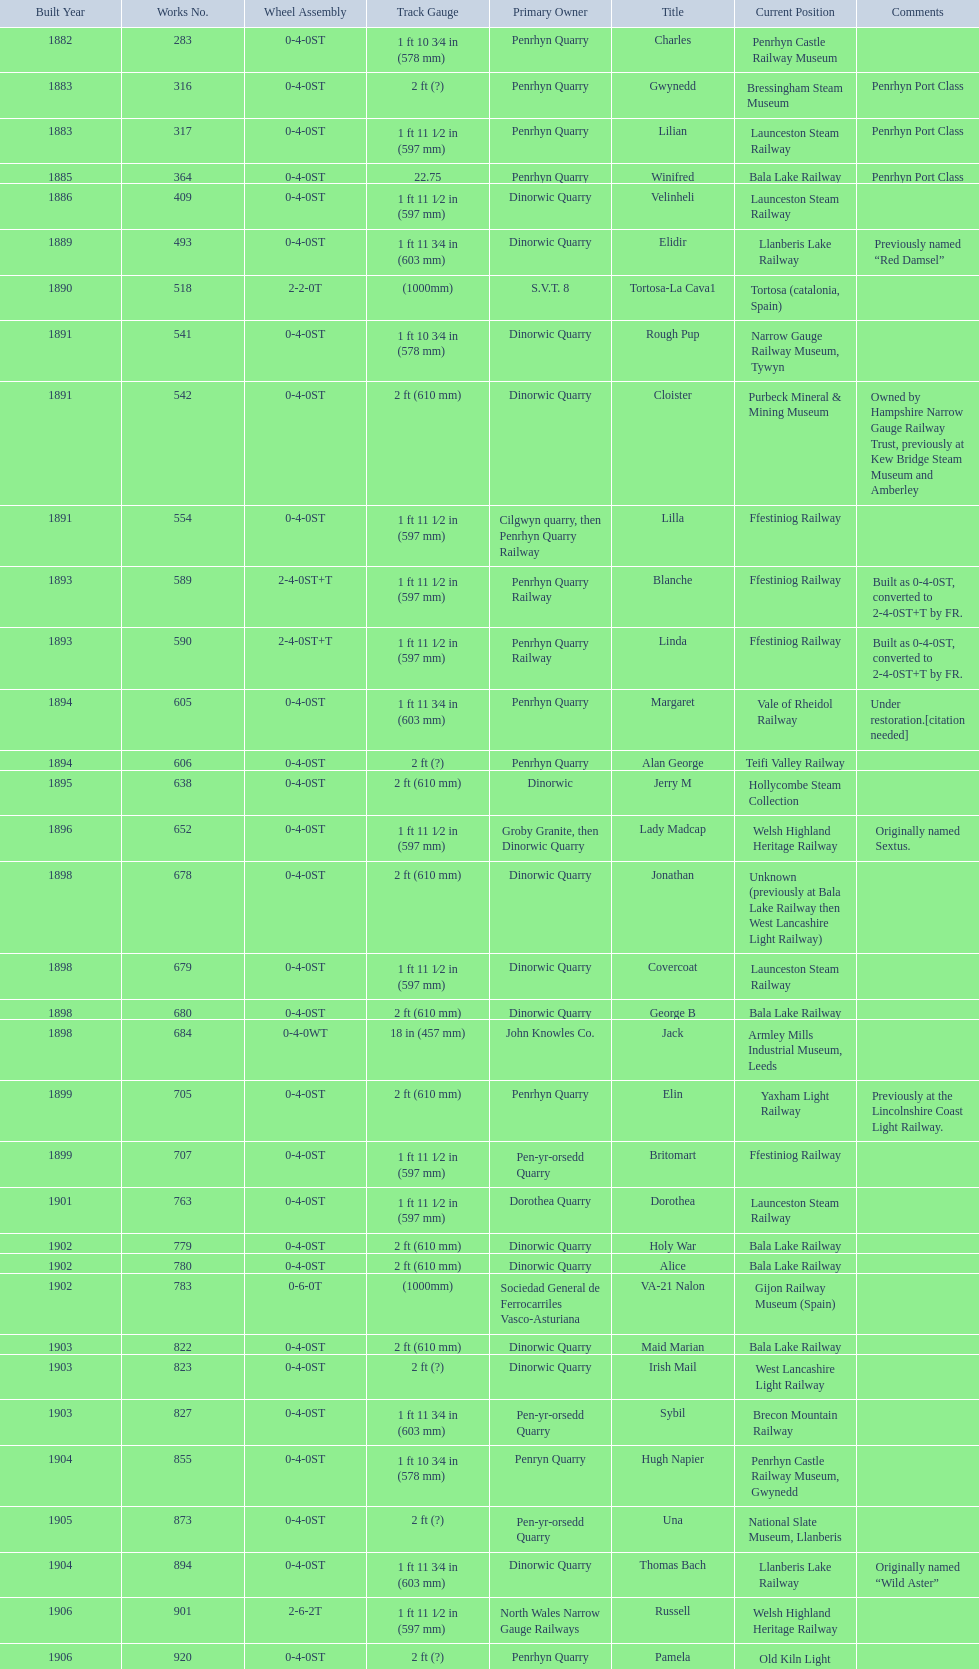After 1940, how many steam locomotives were built? 2. 